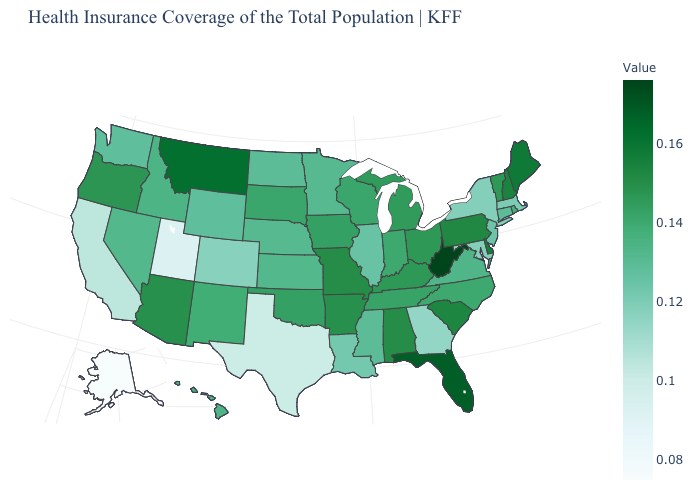Does Alaska have the lowest value in the West?
Write a very short answer. Yes. Which states have the lowest value in the Northeast?
Write a very short answer. New York. Which states have the lowest value in the West?
Give a very brief answer. Alaska. Does the map have missing data?
Write a very short answer. No. Does the map have missing data?
Keep it brief. No. Does New Jersey have a lower value than Alaska?
Short answer required. No. Does Alaska have the lowest value in the West?
Be succinct. Yes. 